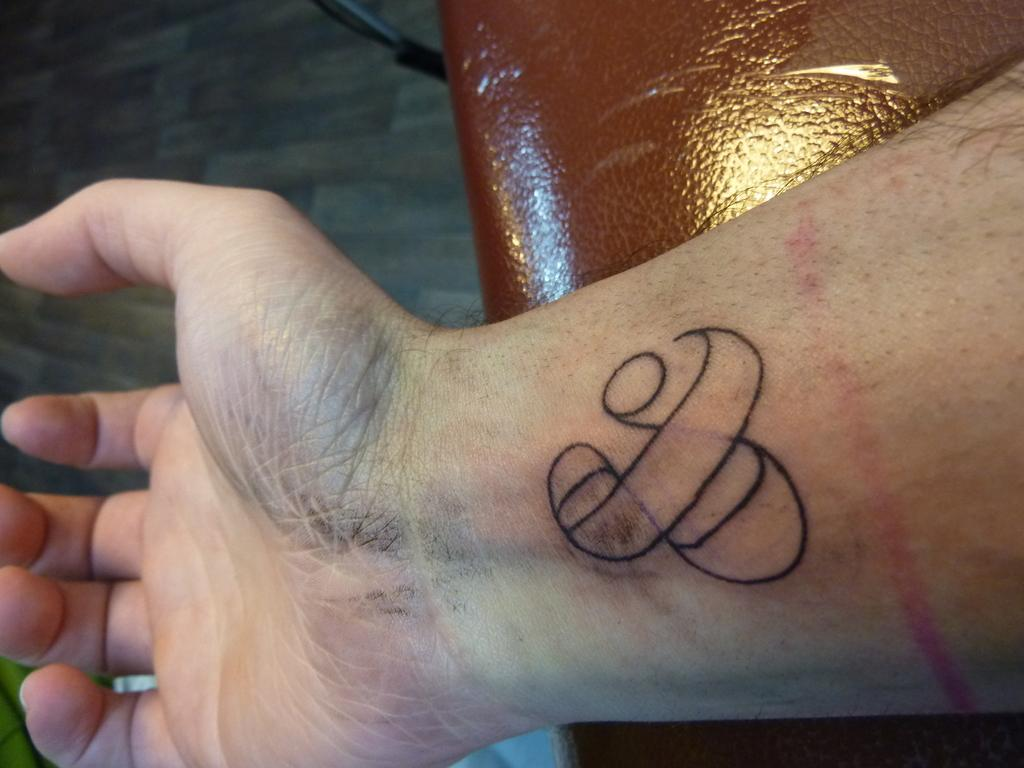What can be seen on the hand in the image? There is a tattoo on a hand in the image. What type of surface is visible beneath the hand? There is a floor visible in the image. Can you describe the object in the image? Unfortunately, the facts provided do not give enough information to describe the object in the image. What type of roof can be seen in the image? There is no roof visible in the image; only a floor and a tattooed hand are present. 